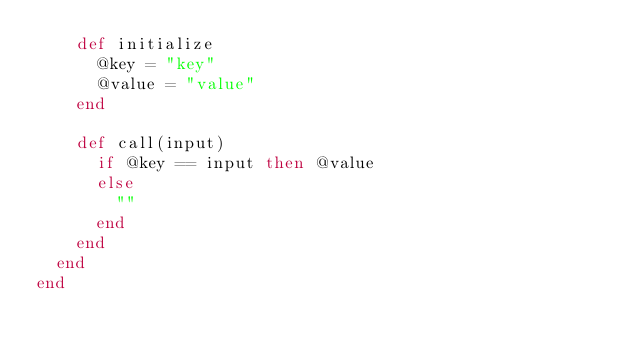Convert code to text. <code><loc_0><loc_0><loc_500><loc_500><_Ruby_>    def initialize
      @key = "key"
      @value = "value"
    end

    def call(input)
      if @key == input then @value
      else
        ""
      end
    end
  end
end
</code> 